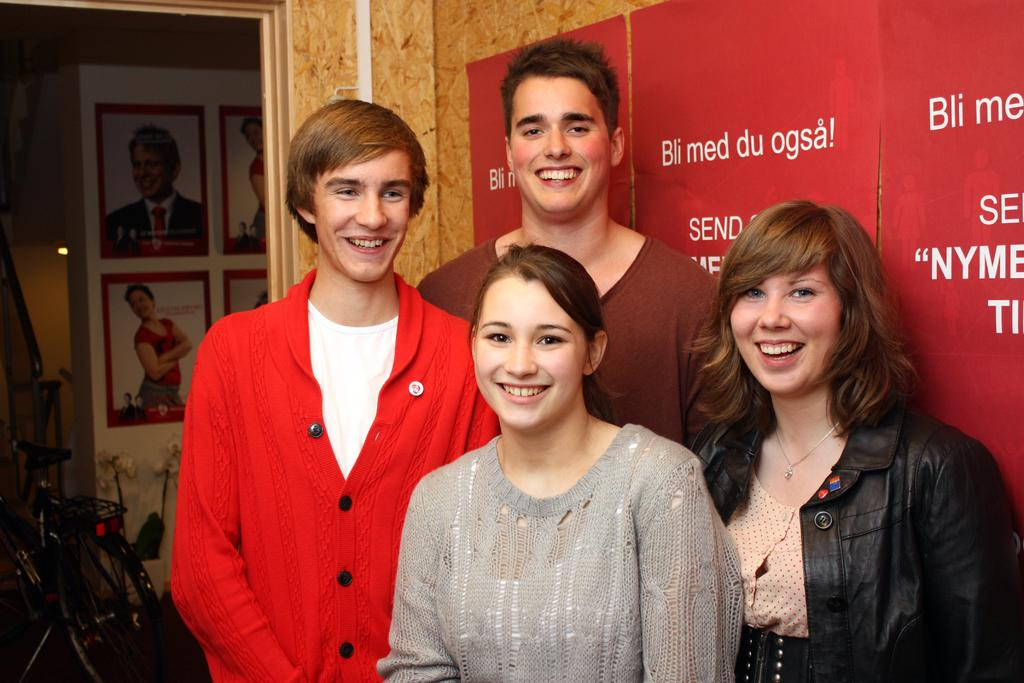What can be seen in the image? There are people standing in the image. What is on the wall in the image? There are posters on the wall in the image. Where is the bicycle located in the image? The bicycle is on the left side of the image. Can you see any visible veins on the people in the image? There is no information about visible veins on the people in the image, so it cannot be determined from the image. 